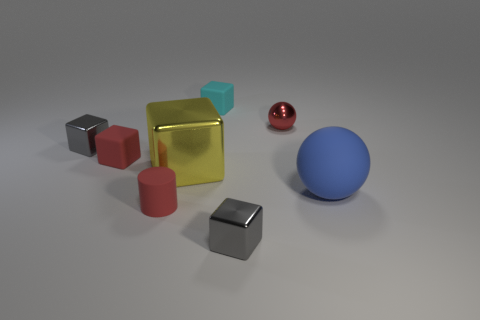The cylinder is what color?
Your answer should be compact. Red. There is a matte thing that is both on the right side of the small cylinder and in front of the cyan matte object; what is its size?
Give a very brief answer. Large. What number of things are small matte cubes that are behind the tiny red sphere or green balls?
Provide a succinct answer. 1. There is a tiny red object that is the same material as the tiny red cylinder; what is its shape?
Provide a succinct answer. Cube. The blue matte object has what shape?
Provide a succinct answer. Sphere. There is a tiny metal thing that is left of the red shiny sphere and behind the red matte block; what color is it?
Offer a terse response. Gray. The shiny object that is the same size as the blue sphere is what shape?
Offer a very short reply. Cube. Are there any red things that have the same shape as the big yellow object?
Ensure brevity in your answer.  Yes. Do the tiny red cube and the tiny gray object in front of the cylinder have the same material?
Make the answer very short. No. There is a cylinder that is to the left of the sphere that is to the right of the tiny ball in front of the cyan rubber block; what color is it?
Provide a succinct answer. Red. 